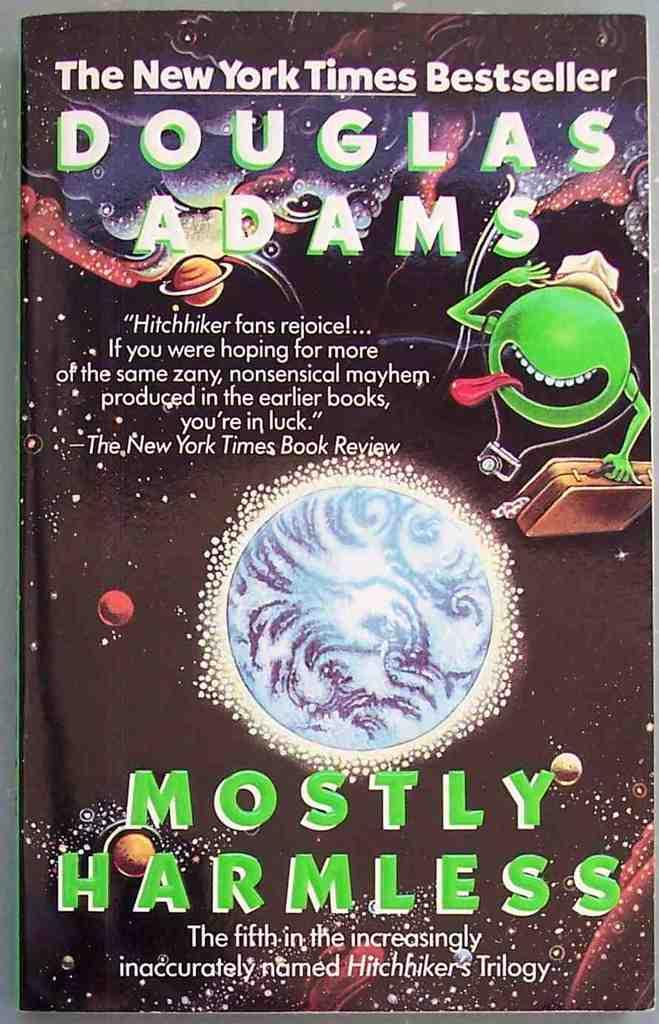<image>
Give a short and clear explanation of the subsequent image. The fifth book in Douglas Adams' Hitchhiker's series. 